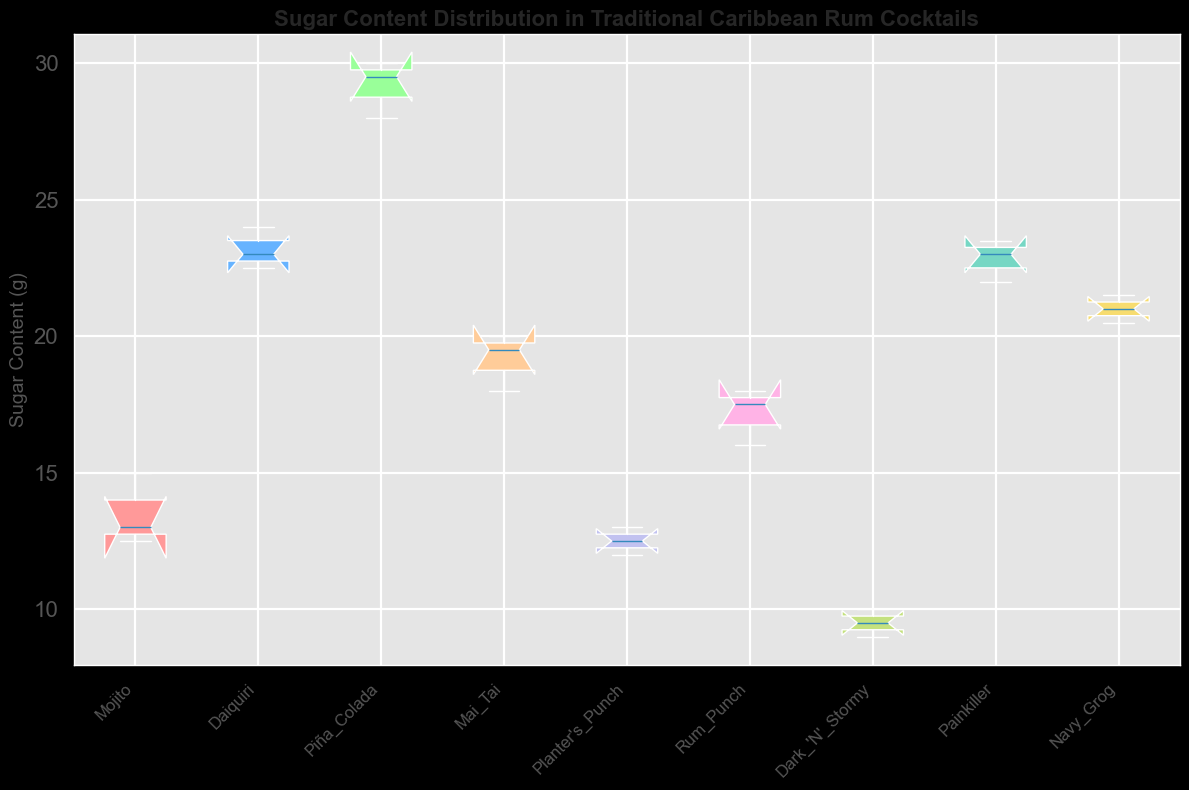What is the range of sugar content in the Piña Colada? To find the range, we subtract the minimum value from the maximum value. The sugar content for Piña Colada ranges from 28.0 to 30.0. Therefore, the range is 30.0 - 28.0 = 2.0 grams.
Answer: 2.0 grams Which cocktail has the highest median sugar content? To determine this, we look at the central line within each box on the plot. The Piña Colada has the highest median value, which is around 29.0 grams.
Answer: Piña Colada Among Mai Tai, Daiquiri, and Painkiller, which has the smallest interquartile range (IQR) of sugar content? The IQR is the range between the first quartile (the bottom of the box) and the third quartile (the top of the box). By visually comparing the heights of the boxes for Mai Tai, Daiquiri, and Painkiller, we see that the IQR for Mai Tai is the smallest.
Answer: Mai Tai Are there any cocktails with an identical median sugar content? The median is represented by the line inside each box. Viewing the plot, no cocktails have exactly the same median sugar content.
Answer: No Which cocktail shows the greatest variability in sugar content? Variability can be estimated by the total range from the bottom whisker to the top whisker. Piña Colada has the greatest range, indicating the highest variability from 28.0 to 30.0 grams, a span of 2.0 grams.
Answer: Piña Colada How does the sugar content of Planter's Punch compare to that of Dark 'N' Stormy? Comparing the median lines and the whiskers for both cocktails, Planter's Punch has a higher median and ranges roughly from 12.0 to 13.0 grams, whereas Dark 'N' Stormy ranges from 9.0 to 10.0 grams. Planter's Punch has a higher sugar content overall.
Answer: Planter's Punch has a higher sugar content What is the median sugar content of the Rum Punch? The median sugar content is represented by the line inside the box of Rum Punch. This line is positioned at about 17.5 grams.
Answer: 17.5 grams Which cocktail has a very close upper and lower quartile, indicating a tight distribution around the median? The tightest box (indicating a small IQR) indicates a tight distribution. The box for Planter's Punch is very small, indicating that the values are close around the median, ranging from 12.0 to 13.0 grams.
Answer: Planter's Punch 